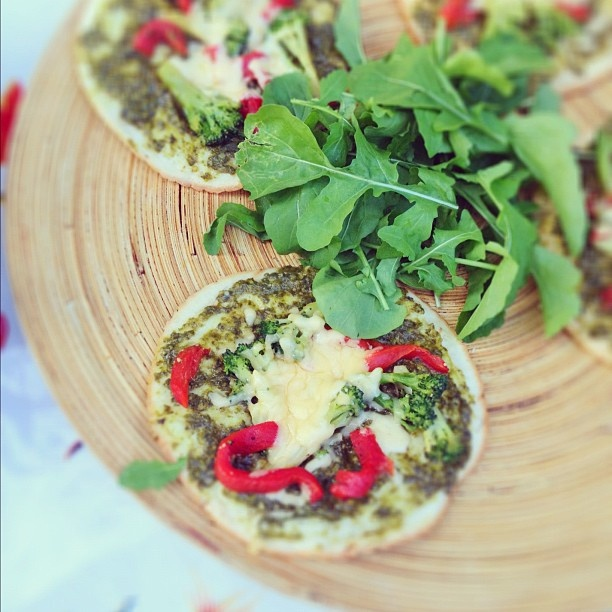Describe the objects in this image and their specific colors. I can see pizza in gray, beige, and olive tones, pizza in gray, olive, and beige tones, broccoli in gray, beige, lightgreen, and darkgray tones, pizza in gray, olive, beige, green, and tan tones, and pizza in gray, olive, and green tones in this image. 